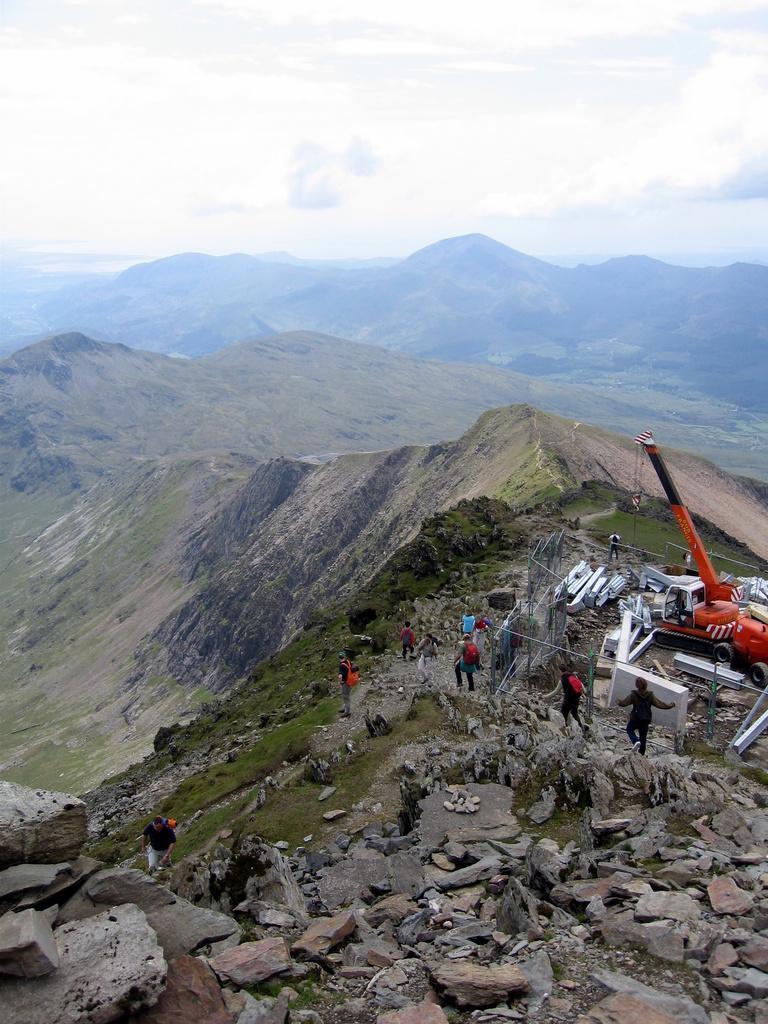In one or two sentences, can you explain what this image depicts? in this image we can see these people are standing on the hills. Here we can see the crane, rocks, hills and sky with clouds in the background. 